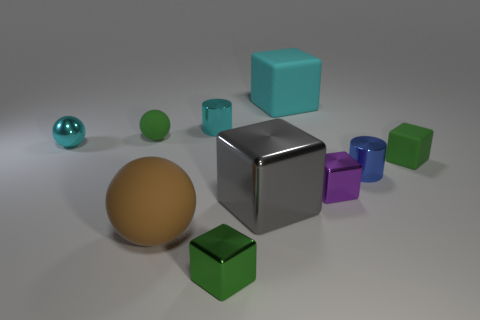Is the gray metal object the same shape as the big cyan thing?
Ensure brevity in your answer.  Yes. How big is the green cube that is left of the gray object?
Provide a short and direct response. Small. Is there a metallic thing of the same color as the big ball?
Your answer should be compact. No. Does the green block to the left of the gray metal object have the same size as the purple metal thing?
Keep it short and to the point. Yes. The big shiny thing has what color?
Your response must be concise. Gray. What color is the tiny matte thing that is behind the rubber cube on the right side of the cyan rubber cube?
Provide a succinct answer. Green. Is there a tiny object that has the same material as the gray cube?
Your response must be concise. Yes. What material is the cyan object left of the cylinder on the left side of the gray block made of?
Offer a very short reply. Metal. What number of shiny things are the same shape as the large cyan rubber object?
Your answer should be very brief. 3. The green shiny object has what shape?
Ensure brevity in your answer.  Cube. 